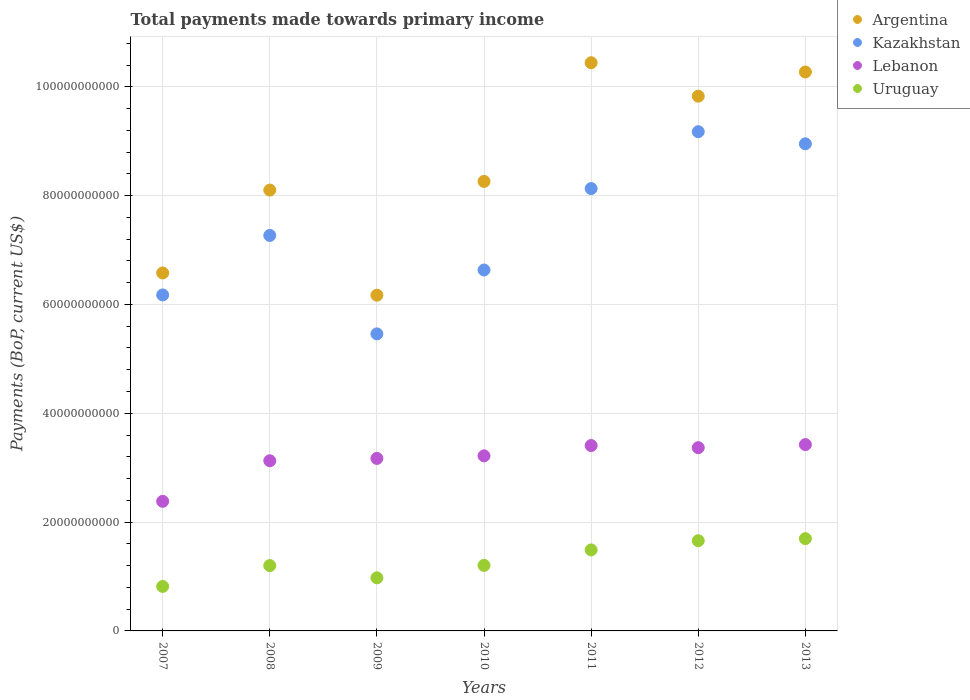How many different coloured dotlines are there?
Give a very brief answer. 4. Is the number of dotlines equal to the number of legend labels?
Make the answer very short. Yes. What is the total payments made towards primary income in Kazakhstan in 2011?
Keep it short and to the point. 8.13e+1. Across all years, what is the maximum total payments made towards primary income in Kazakhstan?
Offer a terse response. 9.18e+1. Across all years, what is the minimum total payments made towards primary income in Argentina?
Give a very brief answer. 6.17e+1. In which year was the total payments made towards primary income in Uruguay maximum?
Give a very brief answer. 2013. What is the total total payments made towards primary income in Argentina in the graph?
Provide a succinct answer. 5.97e+11. What is the difference between the total payments made towards primary income in Lebanon in 2009 and that in 2010?
Offer a very short reply. -4.73e+08. What is the difference between the total payments made towards primary income in Lebanon in 2013 and the total payments made towards primary income in Kazakhstan in 2008?
Your answer should be very brief. -3.84e+1. What is the average total payments made towards primary income in Uruguay per year?
Provide a short and direct response. 1.29e+1. In the year 2013, what is the difference between the total payments made towards primary income in Uruguay and total payments made towards primary income in Kazakhstan?
Your response must be concise. -7.26e+1. In how many years, is the total payments made towards primary income in Lebanon greater than 68000000000 US$?
Give a very brief answer. 0. What is the ratio of the total payments made towards primary income in Lebanon in 2011 to that in 2013?
Ensure brevity in your answer.  0.99. What is the difference between the highest and the second highest total payments made towards primary income in Argentina?
Make the answer very short. 1.70e+09. What is the difference between the highest and the lowest total payments made towards primary income in Kazakhstan?
Provide a succinct answer. 3.72e+1. In how many years, is the total payments made towards primary income in Argentina greater than the average total payments made towards primary income in Argentina taken over all years?
Offer a terse response. 3. Is it the case that in every year, the sum of the total payments made towards primary income in Uruguay and total payments made towards primary income in Kazakhstan  is greater than the total payments made towards primary income in Argentina?
Your answer should be compact. No. Does the total payments made towards primary income in Kazakhstan monotonically increase over the years?
Keep it short and to the point. No. Is the total payments made towards primary income in Uruguay strictly greater than the total payments made towards primary income in Kazakhstan over the years?
Your answer should be very brief. No. Is the total payments made towards primary income in Lebanon strictly less than the total payments made towards primary income in Kazakhstan over the years?
Keep it short and to the point. Yes. How many dotlines are there?
Offer a very short reply. 4. How many years are there in the graph?
Provide a succinct answer. 7. Does the graph contain any zero values?
Your answer should be very brief. No. Does the graph contain grids?
Your answer should be very brief. Yes. Where does the legend appear in the graph?
Provide a short and direct response. Top right. What is the title of the graph?
Your answer should be very brief. Total payments made towards primary income. Does "Mauritius" appear as one of the legend labels in the graph?
Keep it short and to the point. No. What is the label or title of the Y-axis?
Offer a very short reply. Payments (BoP, current US$). What is the Payments (BoP, current US$) in Argentina in 2007?
Your answer should be compact. 6.58e+1. What is the Payments (BoP, current US$) in Kazakhstan in 2007?
Make the answer very short. 6.18e+1. What is the Payments (BoP, current US$) in Lebanon in 2007?
Provide a short and direct response. 2.38e+1. What is the Payments (BoP, current US$) of Uruguay in 2007?
Your answer should be very brief. 8.18e+09. What is the Payments (BoP, current US$) in Argentina in 2008?
Offer a very short reply. 8.10e+1. What is the Payments (BoP, current US$) of Kazakhstan in 2008?
Your answer should be very brief. 7.27e+1. What is the Payments (BoP, current US$) in Lebanon in 2008?
Provide a short and direct response. 3.13e+1. What is the Payments (BoP, current US$) in Uruguay in 2008?
Provide a succinct answer. 1.20e+1. What is the Payments (BoP, current US$) of Argentina in 2009?
Ensure brevity in your answer.  6.17e+1. What is the Payments (BoP, current US$) of Kazakhstan in 2009?
Ensure brevity in your answer.  5.46e+1. What is the Payments (BoP, current US$) of Lebanon in 2009?
Provide a short and direct response. 3.17e+1. What is the Payments (BoP, current US$) of Uruguay in 2009?
Offer a very short reply. 9.76e+09. What is the Payments (BoP, current US$) in Argentina in 2010?
Offer a very short reply. 8.26e+1. What is the Payments (BoP, current US$) in Kazakhstan in 2010?
Provide a short and direct response. 6.63e+1. What is the Payments (BoP, current US$) in Lebanon in 2010?
Give a very brief answer. 3.22e+1. What is the Payments (BoP, current US$) in Uruguay in 2010?
Give a very brief answer. 1.20e+1. What is the Payments (BoP, current US$) of Argentina in 2011?
Ensure brevity in your answer.  1.04e+11. What is the Payments (BoP, current US$) in Kazakhstan in 2011?
Give a very brief answer. 8.13e+1. What is the Payments (BoP, current US$) of Lebanon in 2011?
Offer a terse response. 3.41e+1. What is the Payments (BoP, current US$) in Uruguay in 2011?
Your answer should be compact. 1.49e+1. What is the Payments (BoP, current US$) of Argentina in 2012?
Provide a short and direct response. 9.83e+1. What is the Payments (BoP, current US$) in Kazakhstan in 2012?
Offer a terse response. 9.18e+1. What is the Payments (BoP, current US$) in Lebanon in 2012?
Provide a short and direct response. 3.37e+1. What is the Payments (BoP, current US$) in Uruguay in 2012?
Your response must be concise. 1.66e+1. What is the Payments (BoP, current US$) in Argentina in 2013?
Your answer should be very brief. 1.03e+11. What is the Payments (BoP, current US$) of Kazakhstan in 2013?
Keep it short and to the point. 8.95e+1. What is the Payments (BoP, current US$) of Lebanon in 2013?
Your answer should be very brief. 3.42e+1. What is the Payments (BoP, current US$) in Uruguay in 2013?
Ensure brevity in your answer.  1.70e+1. Across all years, what is the maximum Payments (BoP, current US$) of Argentina?
Offer a terse response. 1.04e+11. Across all years, what is the maximum Payments (BoP, current US$) in Kazakhstan?
Make the answer very short. 9.18e+1. Across all years, what is the maximum Payments (BoP, current US$) of Lebanon?
Offer a terse response. 3.42e+1. Across all years, what is the maximum Payments (BoP, current US$) of Uruguay?
Your answer should be very brief. 1.70e+1. Across all years, what is the minimum Payments (BoP, current US$) in Argentina?
Offer a terse response. 6.17e+1. Across all years, what is the minimum Payments (BoP, current US$) in Kazakhstan?
Provide a short and direct response. 5.46e+1. Across all years, what is the minimum Payments (BoP, current US$) in Lebanon?
Your answer should be compact. 2.38e+1. Across all years, what is the minimum Payments (BoP, current US$) in Uruguay?
Ensure brevity in your answer.  8.18e+09. What is the total Payments (BoP, current US$) in Argentina in the graph?
Make the answer very short. 5.97e+11. What is the total Payments (BoP, current US$) of Kazakhstan in the graph?
Your answer should be compact. 5.18e+11. What is the total Payments (BoP, current US$) in Lebanon in the graph?
Provide a succinct answer. 2.21e+11. What is the total Payments (BoP, current US$) in Uruguay in the graph?
Offer a terse response. 9.04e+1. What is the difference between the Payments (BoP, current US$) of Argentina in 2007 and that in 2008?
Give a very brief answer. -1.52e+1. What is the difference between the Payments (BoP, current US$) of Kazakhstan in 2007 and that in 2008?
Your response must be concise. -1.09e+1. What is the difference between the Payments (BoP, current US$) of Lebanon in 2007 and that in 2008?
Give a very brief answer. -7.46e+09. What is the difference between the Payments (BoP, current US$) in Uruguay in 2007 and that in 2008?
Your answer should be compact. -3.83e+09. What is the difference between the Payments (BoP, current US$) of Argentina in 2007 and that in 2009?
Your answer should be compact. 4.09e+09. What is the difference between the Payments (BoP, current US$) of Kazakhstan in 2007 and that in 2009?
Your answer should be very brief. 7.15e+09. What is the difference between the Payments (BoP, current US$) in Lebanon in 2007 and that in 2009?
Provide a succinct answer. -7.89e+09. What is the difference between the Payments (BoP, current US$) of Uruguay in 2007 and that in 2009?
Your answer should be compact. -1.59e+09. What is the difference between the Payments (BoP, current US$) in Argentina in 2007 and that in 2010?
Your answer should be compact. -1.68e+1. What is the difference between the Payments (BoP, current US$) of Kazakhstan in 2007 and that in 2010?
Provide a short and direct response. -4.59e+09. What is the difference between the Payments (BoP, current US$) in Lebanon in 2007 and that in 2010?
Make the answer very short. -8.36e+09. What is the difference between the Payments (BoP, current US$) in Uruguay in 2007 and that in 2010?
Your response must be concise. -3.87e+09. What is the difference between the Payments (BoP, current US$) in Argentina in 2007 and that in 2011?
Provide a succinct answer. -3.86e+1. What is the difference between the Payments (BoP, current US$) in Kazakhstan in 2007 and that in 2011?
Make the answer very short. -1.96e+1. What is the difference between the Payments (BoP, current US$) in Lebanon in 2007 and that in 2011?
Offer a very short reply. -1.03e+1. What is the difference between the Payments (BoP, current US$) of Uruguay in 2007 and that in 2011?
Your response must be concise. -6.71e+09. What is the difference between the Payments (BoP, current US$) in Argentina in 2007 and that in 2012?
Your answer should be compact. -3.25e+1. What is the difference between the Payments (BoP, current US$) of Kazakhstan in 2007 and that in 2012?
Your response must be concise. -3.00e+1. What is the difference between the Payments (BoP, current US$) of Lebanon in 2007 and that in 2012?
Give a very brief answer. -9.86e+09. What is the difference between the Payments (BoP, current US$) in Uruguay in 2007 and that in 2012?
Give a very brief answer. -8.41e+09. What is the difference between the Payments (BoP, current US$) in Argentina in 2007 and that in 2013?
Make the answer very short. -3.69e+1. What is the difference between the Payments (BoP, current US$) of Kazakhstan in 2007 and that in 2013?
Keep it short and to the point. -2.78e+1. What is the difference between the Payments (BoP, current US$) in Lebanon in 2007 and that in 2013?
Make the answer very short. -1.04e+1. What is the difference between the Payments (BoP, current US$) of Uruguay in 2007 and that in 2013?
Your answer should be very brief. -8.79e+09. What is the difference between the Payments (BoP, current US$) of Argentina in 2008 and that in 2009?
Offer a terse response. 1.93e+1. What is the difference between the Payments (BoP, current US$) in Kazakhstan in 2008 and that in 2009?
Provide a succinct answer. 1.81e+1. What is the difference between the Payments (BoP, current US$) of Lebanon in 2008 and that in 2009?
Give a very brief answer. -4.30e+08. What is the difference between the Payments (BoP, current US$) in Uruguay in 2008 and that in 2009?
Give a very brief answer. 2.24e+09. What is the difference between the Payments (BoP, current US$) in Argentina in 2008 and that in 2010?
Provide a succinct answer. -1.59e+09. What is the difference between the Payments (BoP, current US$) in Kazakhstan in 2008 and that in 2010?
Offer a very short reply. 6.35e+09. What is the difference between the Payments (BoP, current US$) in Lebanon in 2008 and that in 2010?
Give a very brief answer. -9.03e+08. What is the difference between the Payments (BoP, current US$) of Uruguay in 2008 and that in 2010?
Provide a short and direct response. -3.72e+07. What is the difference between the Payments (BoP, current US$) of Argentina in 2008 and that in 2011?
Your response must be concise. -2.34e+1. What is the difference between the Payments (BoP, current US$) of Kazakhstan in 2008 and that in 2011?
Your response must be concise. -8.61e+09. What is the difference between the Payments (BoP, current US$) of Lebanon in 2008 and that in 2011?
Your answer should be compact. -2.80e+09. What is the difference between the Payments (BoP, current US$) in Uruguay in 2008 and that in 2011?
Your answer should be compact. -2.88e+09. What is the difference between the Payments (BoP, current US$) of Argentina in 2008 and that in 2012?
Keep it short and to the point. -1.73e+1. What is the difference between the Payments (BoP, current US$) in Kazakhstan in 2008 and that in 2012?
Give a very brief answer. -1.91e+1. What is the difference between the Payments (BoP, current US$) in Lebanon in 2008 and that in 2012?
Your response must be concise. -2.40e+09. What is the difference between the Payments (BoP, current US$) in Uruguay in 2008 and that in 2012?
Your response must be concise. -4.57e+09. What is the difference between the Payments (BoP, current US$) in Argentina in 2008 and that in 2013?
Your answer should be very brief. -2.17e+1. What is the difference between the Payments (BoP, current US$) of Kazakhstan in 2008 and that in 2013?
Ensure brevity in your answer.  -1.68e+1. What is the difference between the Payments (BoP, current US$) in Lebanon in 2008 and that in 2013?
Provide a succinct answer. -2.97e+09. What is the difference between the Payments (BoP, current US$) of Uruguay in 2008 and that in 2013?
Your answer should be very brief. -4.95e+09. What is the difference between the Payments (BoP, current US$) in Argentina in 2009 and that in 2010?
Give a very brief answer. -2.09e+1. What is the difference between the Payments (BoP, current US$) in Kazakhstan in 2009 and that in 2010?
Keep it short and to the point. -1.17e+1. What is the difference between the Payments (BoP, current US$) in Lebanon in 2009 and that in 2010?
Provide a short and direct response. -4.73e+08. What is the difference between the Payments (BoP, current US$) in Uruguay in 2009 and that in 2010?
Keep it short and to the point. -2.28e+09. What is the difference between the Payments (BoP, current US$) in Argentina in 2009 and that in 2011?
Offer a very short reply. -4.27e+1. What is the difference between the Payments (BoP, current US$) in Kazakhstan in 2009 and that in 2011?
Keep it short and to the point. -2.67e+1. What is the difference between the Payments (BoP, current US$) in Lebanon in 2009 and that in 2011?
Provide a short and direct response. -2.37e+09. What is the difference between the Payments (BoP, current US$) of Uruguay in 2009 and that in 2011?
Your answer should be compact. -5.13e+09. What is the difference between the Payments (BoP, current US$) in Argentina in 2009 and that in 2012?
Make the answer very short. -3.66e+1. What is the difference between the Payments (BoP, current US$) of Kazakhstan in 2009 and that in 2012?
Your response must be concise. -3.72e+1. What is the difference between the Payments (BoP, current US$) of Lebanon in 2009 and that in 2012?
Make the answer very short. -1.98e+09. What is the difference between the Payments (BoP, current US$) of Uruguay in 2009 and that in 2012?
Provide a succinct answer. -6.82e+09. What is the difference between the Payments (BoP, current US$) in Argentina in 2009 and that in 2013?
Keep it short and to the point. -4.10e+1. What is the difference between the Payments (BoP, current US$) in Kazakhstan in 2009 and that in 2013?
Give a very brief answer. -3.49e+1. What is the difference between the Payments (BoP, current US$) in Lebanon in 2009 and that in 2013?
Make the answer very short. -2.54e+09. What is the difference between the Payments (BoP, current US$) of Uruguay in 2009 and that in 2013?
Your answer should be compact. -7.20e+09. What is the difference between the Payments (BoP, current US$) in Argentina in 2010 and that in 2011?
Give a very brief answer. -2.18e+1. What is the difference between the Payments (BoP, current US$) of Kazakhstan in 2010 and that in 2011?
Make the answer very short. -1.50e+1. What is the difference between the Payments (BoP, current US$) in Lebanon in 2010 and that in 2011?
Offer a very short reply. -1.89e+09. What is the difference between the Payments (BoP, current US$) of Uruguay in 2010 and that in 2011?
Ensure brevity in your answer.  -2.85e+09. What is the difference between the Payments (BoP, current US$) of Argentina in 2010 and that in 2012?
Your answer should be very brief. -1.57e+1. What is the difference between the Payments (BoP, current US$) in Kazakhstan in 2010 and that in 2012?
Your answer should be compact. -2.54e+1. What is the difference between the Payments (BoP, current US$) of Lebanon in 2010 and that in 2012?
Give a very brief answer. -1.50e+09. What is the difference between the Payments (BoP, current US$) of Uruguay in 2010 and that in 2012?
Your answer should be very brief. -4.54e+09. What is the difference between the Payments (BoP, current US$) of Argentina in 2010 and that in 2013?
Keep it short and to the point. -2.01e+1. What is the difference between the Payments (BoP, current US$) in Kazakhstan in 2010 and that in 2013?
Provide a short and direct response. -2.32e+1. What is the difference between the Payments (BoP, current US$) in Lebanon in 2010 and that in 2013?
Provide a succinct answer. -2.07e+09. What is the difference between the Payments (BoP, current US$) of Uruguay in 2010 and that in 2013?
Your answer should be compact. -4.92e+09. What is the difference between the Payments (BoP, current US$) of Argentina in 2011 and that in 2012?
Your response must be concise. 6.14e+09. What is the difference between the Payments (BoP, current US$) in Kazakhstan in 2011 and that in 2012?
Keep it short and to the point. -1.05e+1. What is the difference between the Payments (BoP, current US$) in Lebanon in 2011 and that in 2012?
Provide a succinct answer. 3.91e+08. What is the difference between the Payments (BoP, current US$) of Uruguay in 2011 and that in 2012?
Offer a terse response. -1.69e+09. What is the difference between the Payments (BoP, current US$) in Argentina in 2011 and that in 2013?
Ensure brevity in your answer.  1.70e+09. What is the difference between the Payments (BoP, current US$) in Kazakhstan in 2011 and that in 2013?
Your answer should be compact. -8.23e+09. What is the difference between the Payments (BoP, current US$) of Lebanon in 2011 and that in 2013?
Ensure brevity in your answer.  -1.74e+08. What is the difference between the Payments (BoP, current US$) in Uruguay in 2011 and that in 2013?
Make the answer very short. -2.07e+09. What is the difference between the Payments (BoP, current US$) in Argentina in 2012 and that in 2013?
Give a very brief answer. -4.44e+09. What is the difference between the Payments (BoP, current US$) in Kazakhstan in 2012 and that in 2013?
Ensure brevity in your answer.  2.23e+09. What is the difference between the Payments (BoP, current US$) in Lebanon in 2012 and that in 2013?
Offer a terse response. -5.64e+08. What is the difference between the Payments (BoP, current US$) in Uruguay in 2012 and that in 2013?
Offer a terse response. -3.80e+08. What is the difference between the Payments (BoP, current US$) in Argentina in 2007 and the Payments (BoP, current US$) in Kazakhstan in 2008?
Offer a very short reply. -6.89e+09. What is the difference between the Payments (BoP, current US$) in Argentina in 2007 and the Payments (BoP, current US$) in Lebanon in 2008?
Offer a very short reply. 3.45e+1. What is the difference between the Payments (BoP, current US$) of Argentina in 2007 and the Payments (BoP, current US$) of Uruguay in 2008?
Give a very brief answer. 5.38e+1. What is the difference between the Payments (BoP, current US$) of Kazakhstan in 2007 and the Payments (BoP, current US$) of Lebanon in 2008?
Offer a terse response. 3.05e+1. What is the difference between the Payments (BoP, current US$) in Kazakhstan in 2007 and the Payments (BoP, current US$) in Uruguay in 2008?
Your answer should be very brief. 4.97e+1. What is the difference between the Payments (BoP, current US$) of Lebanon in 2007 and the Payments (BoP, current US$) of Uruguay in 2008?
Make the answer very short. 1.18e+1. What is the difference between the Payments (BoP, current US$) in Argentina in 2007 and the Payments (BoP, current US$) in Kazakhstan in 2009?
Provide a short and direct response. 1.12e+1. What is the difference between the Payments (BoP, current US$) of Argentina in 2007 and the Payments (BoP, current US$) of Lebanon in 2009?
Your answer should be very brief. 3.41e+1. What is the difference between the Payments (BoP, current US$) in Argentina in 2007 and the Payments (BoP, current US$) in Uruguay in 2009?
Provide a succinct answer. 5.60e+1. What is the difference between the Payments (BoP, current US$) in Kazakhstan in 2007 and the Payments (BoP, current US$) in Lebanon in 2009?
Provide a short and direct response. 3.00e+1. What is the difference between the Payments (BoP, current US$) in Kazakhstan in 2007 and the Payments (BoP, current US$) in Uruguay in 2009?
Give a very brief answer. 5.20e+1. What is the difference between the Payments (BoP, current US$) in Lebanon in 2007 and the Payments (BoP, current US$) in Uruguay in 2009?
Make the answer very short. 1.41e+1. What is the difference between the Payments (BoP, current US$) of Argentina in 2007 and the Payments (BoP, current US$) of Kazakhstan in 2010?
Offer a terse response. -5.44e+08. What is the difference between the Payments (BoP, current US$) of Argentina in 2007 and the Payments (BoP, current US$) of Lebanon in 2010?
Your answer should be very brief. 3.36e+1. What is the difference between the Payments (BoP, current US$) in Argentina in 2007 and the Payments (BoP, current US$) in Uruguay in 2010?
Your answer should be compact. 5.37e+1. What is the difference between the Payments (BoP, current US$) of Kazakhstan in 2007 and the Payments (BoP, current US$) of Lebanon in 2010?
Your answer should be compact. 2.96e+1. What is the difference between the Payments (BoP, current US$) of Kazakhstan in 2007 and the Payments (BoP, current US$) of Uruguay in 2010?
Your answer should be compact. 4.97e+1. What is the difference between the Payments (BoP, current US$) in Lebanon in 2007 and the Payments (BoP, current US$) in Uruguay in 2010?
Keep it short and to the point. 1.18e+1. What is the difference between the Payments (BoP, current US$) in Argentina in 2007 and the Payments (BoP, current US$) in Kazakhstan in 2011?
Your response must be concise. -1.55e+1. What is the difference between the Payments (BoP, current US$) in Argentina in 2007 and the Payments (BoP, current US$) in Lebanon in 2011?
Provide a succinct answer. 3.17e+1. What is the difference between the Payments (BoP, current US$) in Argentina in 2007 and the Payments (BoP, current US$) in Uruguay in 2011?
Offer a very short reply. 5.09e+1. What is the difference between the Payments (BoP, current US$) in Kazakhstan in 2007 and the Payments (BoP, current US$) in Lebanon in 2011?
Provide a short and direct response. 2.77e+1. What is the difference between the Payments (BoP, current US$) in Kazakhstan in 2007 and the Payments (BoP, current US$) in Uruguay in 2011?
Provide a short and direct response. 4.69e+1. What is the difference between the Payments (BoP, current US$) of Lebanon in 2007 and the Payments (BoP, current US$) of Uruguay in 2011?
Your response must be concise. 8.93e+09. What is the difference between the Payments (BoP, current US$) in Argentina in 2007 and the Payments (BoP, current US$) in Kazakhstan in 2012?
Make the answer very short. -2.60e+1. What is the difference between the Payments (BoP, current US$) in Argentina in 2007 and the Payments (BoP, current US$) in Lebanon in 2012?
Your answer should be compact. 3.21e+1. What is the difference between the Payments (BoP, current US$) of Argentina in 2007 and the Payments (BoP, current US$) of Uruguay in 2012?
Keep it short and to the point. 4.92e+1. What is the difference between the Payments (BoP, current US$) of Kazakhstan in 2007 and the Payments (BoP, current US$) of Lebanon in 2012?
Your answer should be very brief. 2.81e+1. What is the difference between the Payments (BoP, current US$) of Kazakhstan in 2007 and the Payments (BoP, current US$) of Uruguay in 2012?
Make the answer very short. 4.52e+1. What is the difference between the Payments (BoP, current US$) of Lebanon in 2007 and the Payments (BoP, current US$) of Uruguay in 2012?
Make the answer very short. 7.24e+09. What is the difference between the Payments (BoP, current US$) in Argentina in 2007 and the Payments (BoP, current US$) in Kazakhstan in 2013?
Provide a short and direct response. -2.37e+1. What is the difference between the Payments (BoP, current US$) of Argentina in 2007 and the Payments (BoP, current US$) of Lebanon in 2013?
Ensure brevity in your answer.  3.15e+1. What is the difference between the Payments (BoP, current US$) of Argentina in 2007 and the Payments (BoP, current US$) of Uruguay in 2013?
Your response must be concise. 4.88e+1. What is the difference between the Payments (BoP, current US$) in Kazakhstan in 2007 and the Payments (BoP, current US$) in Lebanon in 2013?
Offer a terse response. 2.75e+1. What is the difference between the Payments (BoP, current US$) in Kazakhstan in 2007 and the Payments (BoP, current US$) in Uruguay in 2013?
Your answer should be compact. 4.48e+1. What is the difference between the Payments (BoP, current US$) of Lebanon in 2007 and the Payments (BoP, current US$) of Uruguay in 2013?
Ensure brevity in your answer.  6.86e+09. What is the difference between the Payments (BoP, current US$) of Argentina in 2008 and the Payments (BoP, current US$) of Kazakhstan in 2009?
Your answer should be very brief. 2.64e+1. What is the difference between the Payments (BoP, current US$) of Argentina in 2008 and the Payments (BoP, current US$) of Lebanon in 2009?
Make the answer very short. 4.93e+1. What is the difference between the Payments (BoP, current US$) in Argentina in 2008 and the Payments (BoP, current US$) in Uruguay in 2009?
Give a very brief answer. 7.13e+1. What is the difference between the Payments (BoP, current US$) in Kazakhstan in 2008 and the Payments (BoP, current US$) in Lebanon in 2009?
Give a very brief answer. 4.10e+1. What is the difference between the Payments (BoP, current US$) of Kazakhstan in 2008 and the Payments (BoP, current US$) of Uruguay in 2009?
Offer a very short reply. 6.29e+1. What is the difference between the Payments (BoP, current US$) in Lebanon in 2008 and the Payments (BoP, current US$) in Uruguay in 2009?
Provide a short and direct response. 2.15e+1. What is the difference between the Payments (BoP, current US$) of Argentina in 2008 and the Payments (BoP, current US$) of Kazakhstan in 2010?
Give a very brief answer. 1.47e+1. What is the difference between the Payments (BoP, current US$) of Argentina in 2008 and the Payments (BoP, current US$) of Lebanon in 2010?
Make the answer very short. 4.88e+1. What is the difference between the Payments (BoP, current US$) in Argentina in 2008 and the Payments (BoP, current US$) in Uruguay in 2010?
Give a very brief answer. 6.90e+1. What is the difference between the Payments (BoP, current US$) of Kazakhstan in 2008 and the Payments (BoP, current US$) of Lebanon in 2010?
Your answer should be compact. 4.05e+1. What is the difference between the Payments (BoP, current US$) in Kazakhstan in 2008 and the Payments (BoP, current US$) in Uruguay in 2010?
Your answer should be compact. 6.06e+1. What is the difference between the Payments (BoP, current US$) in Lebanon in 2008 and the Payments (BoP, current US$) in Uruguay in 2010?
Your answer should be compact. 1.92e+1. What is the difference between the Payments (BoP, current US$) in Argentina in 2008 and the Payments (BoP, current US$) in Kazakhstan in 2011?
Make the answer very short. -2.78e+08. What is the difference between the Payments (BoP, current US$) of Argentina in 2008 and the Payments (BoP, current US$) of Lebanon in 2011?
Offer a terse response. 4.70e+1. What is the difference between the Payments (BoP, current US$) in Argentina in 2008 and the Payments (BoP, current US$) in Uruguay in 2011?
Ensure brevity in your answer.  6.61e+1. What is the difference between the Payments (BoP, current US$) in Kazakhstan in 2008 and the Payments (BoP, current US$) in Lebanon in 2011?
Your response must be concise. 3.86e+1. What is the difference between the Payments (BoP, current US$) of Kazakhstan in 2008 and the Payments (BoP, current US$) of Uruguay in 2011?
Offer a terse response. 5.78e+1. What is the difference between the Payments (BoP, current US$) of Lebanon in 2008 and the Payments (BoP, current US$) of Uruguay in 2011?
Offer a very short reply. 1.64e+1. What is the difference between the Payments (BoP, current US$) of Argentina in 2008 and the Payments (BoP, current US$) of Kazakhstan in 2012?
Give a very brief answer. -1.07e+1. What is the difference between the Payments (BoP, current US$) of Argentina in 2008 and the Payments (BoP, current US$) of Lebanon in 2012?
Keep it short and to the point. 4.73e+1. What is the difference between the Payments (BoP, current US$) in Argentina in 2008 and the Payments (BoP, current US$) in Uruguay in 2012?
Provide a succinct answer. 6.44e+1. What is the difference between the Payments (BoP, current US$) in Kazakhstan in 2008 and the Payments (BoP, current US$) in Lebanon in 2012?
Offer a terse response. 3.90e+1. What is the difference between the Payments (BoP, current US$) of Kazakhstan in 2008 and the Payments (BoP, current US$) of Uruguay in 2012?
Offer a very short reply. 5.61e+1. What is the difference between the Payments (BoP, current US$) in Lebanon in 2008 and the Payments (BoP, current US$) in Uruguay in 2012?
Make the answer very short. 1.47e+1. What is the difference between the Payments (BoP, current US$) of Argentina in 2008 and the Payments (BoP, current US$) of Kazakhstan in 2013?
Provide a short and direct response. -8.50e+09. What is the difference between the Payments (BoP, current US$) in Argentina in 2008 and the Payments (BoP, current US$) in Lebanon in 2013?
Your answer should be very brief. 4.68e+1. What is the difference between the Payments (BoP, current US$) of Argentina in 2008 and the Payments (BoP, current US$) of Uruguay in 2013?
Provide a succinct answer. 6.41e+1. What is the difference between the Payments (BoP, current US$) in Kazakhstan in 2008 and the Payments (BoP, current US$) in Lebanon in 2013?
Ensure brevity in your answer.  3.84e+1. What is the difference between the Payments (BoP, current US$) in Kazakhstan in 2008 and the Payments (BoP, current US$) in Uruguay in 2013?
Provide a succinct answer. 5.57e+1. What is the difference between the Payments (BoP, current US$) of Lebanon in 2008 and the Payments (BoP, current US$) of Uruguay in 2013?
Provide a short and direct response. 1.43e+1. What is the difference between the Payments (BoP, current US$) in Argentina in 2009 and the Payments (BoP, current US$) in Kazakhstan in 2010?
Give a very brief answer. -4.63e+09. What is the difference between the Payments (BoP, current US$) of Argentina in 2009 and the Payments (BoP, current US$) of Lebanon in 2010?
Offer a terse response. 2.95e+1. What is the difference between the Payments (BoP, current US$) in Argentina in 2009 and the Payments (BoP, current US$) in Uruguay in 2010?
Provide a short and direct response. 4.97e+1. What is the difference between the Payments (BoP, current US$) in Kazakhstan in 2009 and the Payments (BoP, current US$) in Lebanon in 2010?
Make the answer very short. 2.24e+1. What is the difference between the Payments (BoP, current US$) of Kazakhstan in 2009 and the Payments (BoP, current US$) of Uruguay in 2010?
Your answer should be compact. 4.26e+1. What is the difference between the Payments (BoP, current US$) in Lebanon in 2009 and the Payments (BoP, current US$) in Uruguay in 2010?
Your response must be concise. 1.97e+1. What is the difference between the Payments (BoP, current US$) in Argentina in 2009 and the Payments (BoP, current US$) in Kazakhstan in 2011?
Provide a succinct answer. -1.96e+1. What is the difference between the Payments (BoP, current US$) of Argentina in 2009 and the Payments (BoP, current US$) of Lebanon in 2011?
Offer a terse response. 2.76e+1. What is the difference between the Payments (BoP, current US$) in Argentina in 2009 and the Payments (BoP, current US$) in Uruguay in 2011?
Keep it short and to the point. 4.68e+1. What is the difference between the Payments (BoP, current US$) in Kazakhstan in 2009 and the Payments (BoP, current US$) in Lebanon in 2011?
Your answer should be compact. 2.05e+1. What is the difference between the Payments (BoP, current US$) in Kazakhstan in 2009 and the Payments (BoP, current US$) in Uruguay in 2011?
Keep it short and to the point. 3.97e+1. What is the difference between the Payments (BoP, current US$) of Lebanon in 2009 and the Payments (BoP, current US$) of Uruguay in 2011?
Give a very brief answer. 1.68e+1. What is the difference between the Payments (BoP, current US$) of Argentina in 2009 and the Payments (BoP, current US$) of Kazakhstan in 2012?
Keep it short and to the point. -3.00e+1. What is the difference between the Payments (BoP, current US$) of Argentina in 2009 and the Payments (BoP, current US$) of Lebanon in 2012?
Ensure brevity in your answer.  2.80e+1. What is the difference between the Payments (BoP, current US$) of Argentina in 2009 and the Payments (BoP, current US$) of Uruguay in 2012?
Your answer should be compact. 4.51e+1. What is the difference between the Payments (BoP, current US$) of Kazakhstan in 2009 and the Payments (BoP, current US$) of Lebanon in 2012?
Your answer should be very brief. 2.09e+1. What is the difference between the Payments (BoP, current US$) of Kazakhstan in 2009 and the Payments (BoP, current US$) of Uruguay in 2012?
Your answer should be very brief. 3.80e+1. What is the difference between the Payments (BoP, current US$) in Lebanon in 2009 and the Payments (BoP, current US$) in Uruguay in 2012?
Provide a succinct answer. 1.51e+1. What is the difference between the Payments (BoP, current US$) in Argentina in 2009 and the Payments (BoP, current US$) in Kazakhstan in 2013?
Make the answer very short. -2.78e+1. What is the difference between the Payments (BoP, current US$) of Argentina in 2009 and the Payments (BoP, current US$) of Lebanon in 2013?
Your response must be concise. 2.75e+1. What is the difference between the Payments (BoP, current US$) of Argentina in 2009 and the Payments (BoP, current US$) of Uruguay in 2013?
Keep it short and to the point. 4.47e+1. What is the difference between the Payments (BoP, current US$) in Kazakhstan in 2009 and the Payments (BoP, current US$) in Lebanon in 2013?
Offer a very short reply. 2.04e+1. What is the difference between the Payments (BoP, current US$) in Kazakhstan in 2009 and the Payments (BoP, current US$) in Uruguay in 2013?
Give a very brief answer. 3.76e+1. What is the difference between the Payments (BoP, current US$) in Lebanon in 2009 and the Payments (BoP, current US$) in Uruguay in 2013?
Provide a succinct answer. 1.47e+1. What is the difference between the Payments (BoP, current US$) of Argentina in 2010 and the Payments (BoP, current US$) of Kazakhstan in 2011?
Your answer should be compact. 1.31e+09. What is the difference between the Payments (BoP, current US$) in Argentina in 2010 and the Payments (BoP, current US$) in Lebanon in 2011?
Offer a very short reply. 4.85e+1. What is the difference between the Payments (BoP, current US$) of Argentina in 2010 and the Payments (BoP, current US$) of Uruguay in 2011?
Your response must be concise. 6.77e+1. What is the difference between the Payments (BoP, current US$) of Kazakhstan in 2010 and the Payments (BoP, current US$) of Lebanon in 2011?
Give a very brief answer. 3.23e+1. What is the difference between the Payments (BoP, current US$) in Kazakhstan in 2010 and the Payments (BoP, current US$) in Uruguay in 2011?
Your answer should be compact. 5.14e+1. What is the difference between the Payments (BoP, current US$) in Lebanon in 2010 and the Payments (BoP, current US$) in Uruguay in 2011?
Offer a very short reply. 1.73e+1. What is the difference between the Payments (BoP, current US$) of Argentina in 2010 and the Payments (BoP, current US$) of Kazakhstan in 2012?
Keep it short and to the point. -9.14e+09. What is the difference between the Payments (BoP, current US$) in Argentina in 2010 and the Payments (BoP, current US$) in Lebanon in 2012?
Ensure brevity in your answer.  4.89e+1. What is the difference between the Payments (BoP, current US$) of Argentina in 2010 and the Payments (BoP, current US$) of Uruguay in 2012?
Your answer should be compact. 6.60e+1. What is the difference between the Payments (BoP, current US$) in Kazakhstan in 2010 and the Payments (BoP, current US$) in Lebanon in 2012?
Give a very brief answer. 3.27e+1. What is the difference between the Payments (BoP, current US$) of Kazakhstan in 2010 and the Payments (BoP, current US$) of Uruguay in 2012?
Keep it short and to the point. 4.98e+1. What is the difference between the Payments (BoP, current US$) of Lebanon in 2010 and the Payments (BoP, current US$) of Uruguay in 2012?
Ensure brevity in your answer.  1.56e+1. What is the difference between the Payments (BoP, current US$) of Argentina in 2010 and the Payments (BoP, current US$) of Kazakhstan in 2013?
Ensure brevity in your answer.  -6.91e+09. What is the difference between the Payments (BoP, current US$) of Argentina in 2010 and the Payments (BoP, current US$) of Lebanon in 2013?
Make the answer very short. 4.84e+1. What is the difference between the Payments (BoP, current US$) in Argentina in 2010 and the Payments (BoP, current US$) in Uruguay in 2013?
Make the answer very short. 6.57e+1. What is the difference between the Payments (BoP, current US$) in Kazakhstan in 2010 and the Payments (BoP, current US$) in Lebanon in 2013?
Your response must be concise. 3.21e+1. What is the difference between the Payments (BoP, current US$) of Kazakhstan in 2010 and the Payments (BoP, current US$) of Uruguay in 2013?
Provide a succinct answer. 4.94e+1. What is the difference between the Payments (BoP, current US$) in Lebanon in 2010 and the Payments (BoP, current US$) in Uruguay in 2013?
Offer a terse response. 1.52e+1. What is the difference between the Payments (BoP, current US$) in Argentina in 2011 and the Payments (BoP, current US$) in Kazakhstan in 2012?
Keep it short and to the point. 1.27e+1. What is the difference between the Payments (BoP, current US$) in Argentina in 2011 and the Payments (BoP, current US$) in Lebanon in 2012?
Keep it short and to the point. 7.07e+1. What is the difference between the Payments (BoP, current US$) in Argentina in 2011 and the Payments (BoP, current US$) in Uruguay in 2012?
Your response must be concise. 8.78e+1. What is the difference between the Payments (BoP, current US$) of Kazakhstan in 2011 and the Payments (BoP, current US$) of Lebanon in 2012?
Make the answer very short. 4.76e+1. What is the difference between the Payments (BoP, current US$) in Kazakhstan in 2011 and the Payments (BoP, current US$) in Uruguay in 2012?
Your answer should be very brief. 6.47e+1. What is the difference between the Payments (BoP, current US$) in Lebanon in 2011 and the Payments (BoP, current US$) in Uruguay in 2012?
Provide a succinct answer. 1.75e+1. What is the difference between the Payments (BoP, current US$) of Argentina in 2011 and the Payments (BoP, current US$) of Kazakhstan in 2013?
Your response must be concise. 1.49e+1. What is the difference between the Payments (BoP, current US$) of Argentina in 2011 and the Payments (BoP, current US$) of Lebanon in 2013?
Give a very brief answer. 7.02e+1. What is the difference between the Payments (BoP, current US$) of Argentina in 2011 and the Payments (BoP, current US$) of Uruguay in 2013?
Make the answer very short. 8.75e+1. What is the difference between the Payments (BoP, current US$) of Kazakhstan in 2011 and the Payments (BoP, current US$) of Lebanon in 2013?
Your answer should be compact. 4.71e+1. What is the difference between the Payments (BoP, current US$) in Kazakhstan in 2011 and the Payments (BoP, current US$) in Uruguay in 2013?
Offer a very short reply. 6.43e+1. What is the difference between the Payments (BoP, current US$) in Lebanon in 2011 and the Payments (BoP, current US$) in Uruguay in 2013?
Your answer should be very brief. 1.71e+1. What is the difference between the Payments (BoP, current US$) of Argentina in 2012 and the Payments (BoP, current US$) of Kazakhstan in 2013?
Offer a terse response. 8.76e+09. What is the difference between the Payments (BoP, current US$) of Argentina in 2012 and the Payments (BoP, current US$) of Lebanon in 2013?
Make the answer very short. 6.40e+1. What is the difference between the Payments (BoP, current US$) of Argentina in 2012 and the Payments (BoP, current US$) of Uruguay in 2013?
Your response must be concise. 8.13e+1. What is the difference between the Payments (BoP, current US$) of Kazakhstan in 2012 and the Payments (BoP, current US$) of Lebanon in 2013?
Give a very brief answer. 5.75e+1. What is the difference between the Payments (BoP, current US$) of Kazakhstan in 2012 and the Payments (BoP, current US$) of Uruguay in 2013?
Provide a short and direct response. 7.48e+1. What is the difference between the Payments (BoP, current US$) in Lebanon in 2012 and the Payments (BoP, current US$) in Uruguay in 2013?
Provide a short and direct response. 1.67e+1. What is the average Payments (BoP, current US$) of Argentina per year?
Your answer should be very brief. 8.52e+1. What is the average Payments (BoP, current US$) in Kazakhstan per year?
Your answer should be very brief. 7.40e+1. What is the average Payments (BoP, current US$) in Lebanon per year?
Your answer should be very brief. 3.16e+1. What is the average Payments (BoP, current US$) of Uruguay per year?
Your response must be concise. 1.29e+1. In the year 2007, what is the difference between the Payments (BoP, current US$) in Argentina and Payments (BoP, current US$) in Kazakhstan?
Your response must be concise. 4.04e+09. In the year 2007, what is the difference between the Payments (BoP, current US$) in Argentina and Payments (BoP, current US$) in Lebanon?
Make the answer very short. 4.20e+1. In the year 2007, what is the difference between the Payments (BoP, current US$) of Argentina and Payments (BoP, current US$) of Uruguay?
Ensure brevity in your answer.  5.76e+1. In the year 2007, what is the difference between the Payments (BoP, current US$) of Kazakhstan and Payments (BoP, current US$) of Lebanon?
Give a very brief answer. 3.79e+1. In the year 2007, what is the difference between the Payments (BoP, current US$) in Kazakhstan and Payments (BoP, current US$) in Uruguay?
Keep it short and to the point. 5.36e+1. In the year 2007, what is the difference between the Payments (BoP, current US$) of Lebanon and Payments (BoP, current US$) of Uruguay?
Your response must be concise. 1.56e+1. In the year 2008, what is the difference between the Payments (BoP, current US$) in Argentina and Payments (BoP, current US$) in Kazakhstan?
Your answer should be compact. 8.34e+09. In the year 2008, what is the difference between the Payments (BoP, current US$) of Argentina and Payments (BoP, current US$) of Lebanon?
Offer a terse response. 4.97e+1. In the year 2008, what is the difference between the Payments (BoP, current US$) of Argentina and Payments (BoP, current US$) of Uruguay?
Give a very brief answer. 6.90e+1. In the year 2008, what is the difference between the Payments (BoP, current US$) in Kazakhstan and Payments (BoP, current US$) in Lebanon?
Keep it short and to the point. 4.14e+1. In the year 2008, what is the difference between the Payments (BoP, current US$) of Kazakhstan and Payments (BoP, current US$) of Uruguay?
Provide a succinct answer. 6.07e+1. In the year 2008, what is the difference between the Payments (BoP, current US$) of Lebanon and Payments (BoP, current US$) of Uruguay?
Offer a terse response. 1.93e+1. In the year 2009, what is the difference between the Payments (BoP, current US$) of Argentina and Payments (BoP, current US$) of Kazakhstan?
Make the answer very short. 7.11e+09. In the year 2009, what is the difference between the Payments (BoP, current US$) of Argentina and Payments (BoP, current US$) of Lebanon?
Your response must be concise. 3.00e+1. In the year 2009, what is the difference between the Payments (BoP, current US$) in Argentina and Payments (BoP, current US$) in Uruguay?
Provide a succinct answer. 5.19e+1. In the year 2009, what is the difference between the Payments (BoP, current US$) in Kazakhstan and Payments (BoP, current US$) in Lebanon?
Provide a succinct answer. 2.29e+1. In the year 2009, what is the difference between the Payments (BoP, current US$) in Kazakhstan and Payments (BoP, current US$) in Uruguay?
Provide a short and direct response. 4.48e+1. In the year 2009, what is the difference between the Payments (BoP, current US$) of Lebanon and Payments (BoP, current US$) of Uruguay?
Your response must be concise. 2.19e+1. In the year 2010, what is the difference between the Payments (BoP, current US$) of Argentina and Payments (BoP, current US$) of Kazakhstan?
Provide a short and direct response. 1.63e+1. In the year 2010, what is the difference between the Payments (BoP, current US$) of Argentina and Payments (BoP, current US$) of Lebanon?
Ensure brevity in your answer.  5.04e+1. In the year 2010, what is the difference between the Payments (BoP, current US$) in Argentina and Payments (BoP, current US$) in Uruguay?
Provide a short and direct response. 7.06e+1. In the year 2010, what is the difference between the Payments (BoP, current US$) in Kazakhstan and Payments (BoP, current US$) in Lebanon?
Keep it short and to the point. 3.42e+1. In the year 2010, what is the difference between the Payments (BoP, current US$) of Kazakhstan and Payments (BoP, current US$) of Uruguay?
Offer a terse response. 5.43e+1. In the year 2010, what is the difference between the Payments (BoP, current US$) of Lebanon and Payments (BoP, current US$) of Uruguay?
Make the answer very short. 2.01e+1. In the year 2011, what is the difference between the Payments (BoP, current US$) in Argentina and Payments (BoP, current US$) in Kazakhstan?
Offer a very short reply. 2.31e+1. In the year 2011, what is the difference between the Payments (BoP, current US$) of Argentina and Payments (BoP, current US$) of Lebanon?
Make the answer very short. 7.04e+1. In the year 2011, what is the difference between the Payments (BoP, current US$) of Argentina and Payments (BoP, current US$) of Uruguay?
Keep it short and to the point. 8.95e+1. In the year 2011, what is the difference between the Payments (BoP, current US$) of Kazakhstan and Payments (BoP, current US$) of Lebanon?
Provide a short and direct response. 4.72e+1. In the year 2011, what is the difference between the Payments (BoP, current US$) in Kazakhstan and Payments (BoP, current US$) in Uruguay?
Make the answer very short. 6.64e+1. In the year 2011, what is the difference between the Payments (BoP, current US$) in Lebanon and Payments (BoP, current US$) in Uruguay?
Keep it short and to the point. 1.92e+1. In the year 2012, what is the difference between the Payments (BoP, current US$) in Argentina and Payments (BoP, current US$) in Kazakhstan?
Offer a terse response. 6.53e+09. In the year 2012, what is the difference between the Payments (BoP, current US$) of Argentina and Payments (BoP, current US$) of Lebanon?
Ensure brevity in your answer.  6.46e+1. In the year 2012, what is the difference between the Payments (BoP, current US$) in Argentina and Payments (BoP, current US$) in Uruguay?
Your response must be concise. 8.17e+1. In the year 2012, what is the difference between the Payments (BoP, current US$) of Kazakhstan and Payments (BoP, current US$) of Lebanon?
Ensure brevity in your answer.  5.81e+1. In the year 2012, what is the difference between the Payments (BoP, current US$) in Kazakhstan and Payments (BoP, current US$) in Uruguay?
Keep it short and to the point. 7.52e+1. In the year 2012, what is the difference between the Payments (BoP, current US$) of Lebanon and Payments (BoP, current US$) of Uruguay?
Give a very brief answer. 1.71e+1. In the year 2013, what is the difference between the Payments (BoP, current US$) of Argentina and Payments (BoP, current US$) of Kazakhstan?
Give a very brief answer. 1.32e+1. In the year 2013, what is the difference between the Payments (BoP, current US$) of Argentina and Payments (BoP, current US$) of Lebanon?
Provide a short and direct response. 6.85e+1. In the year 2013, what is the difference between the Payments (BoP, current US$) of Argentina and Payments (BoP, current US$) of Uruguay?
Your answer should be compact. 8.58e+1. In the year 2013, what is the difference between the Payments (BoP, current US$) in Kazakhstan and Payments (BoP, current US$) in Lebanon?
Your response must be concise. 5.53e+1. In the year 2013, what is the difference between the Payments (BoP, current US$) in Kazakhstan and Payments (BoP, current US$) in Uruguay?
Your response must be concise. 7.26e+1. In the year 2013, what is the difference between the Payments (BoP, current US$) in Lebanon and Payments (BoP, current US$) in Uruguay?
Offer a very short reply. 1.73e+1. What is the ratio of the Payments (BoP, current US$) of Argentina in 2007 to that in 2008?
Ensure brevity in your answer.  0.81. What is the ratio of the Payments (BoP, current US$) in Kazakhstan in 2007 to that in 2008?
Your response must be concise. 0.85. What is the ratio of the Payments (BoP, current US$) of Lebanon in 2007 to that in 2008?
Provide a short and direct response. 0.76. What is the ratio of the Payments (BoP, current US$) in Uruguay in 2007 to that in 2008?
Provide a succinct answer. 0.68. What is the ratio of the Payments (BoP, current US$) of Argentina in 2007 to that in 2009?
Offer a terse response. 1.07. What is the ratio of the Payments (BoP, current US$) of Kazakhstan in 2007 to that in 2009?
Keep it short and to the point. 1.13. What is the ratio of the Payments (BoP, current US$) in Lebanon in 2007 to that in 2009?
Your answer should be very brief. 0.75. What is the ratio of the Payments (BoP, current US$) of Uruguay in 2007 to that in 2009?
Your answer should be very brief. 0.84. What is the ratio of the Payments (BoP, current US$) of Argentina in 2007 to that in 2010?
Your answer should be compact. 0.8. What is the ratio of the Payments (BoP, current US$) in Kazakhstan in 2007 to that in 2010?
Ensure brevity in your answer.  0.93. What is the ratio of the Payments (BoP, current US$) of Lebanon in 2007 to that in 2010?
Offer a terse response. 0.74. What is the ratio of the Payments (BoP, current US$) of Uruguay in 2007 to that in 2010?
Offer a terse response. 0.68. What is the ratio of the Payments (BoP, current US$) of Argentina in 2007 to that in 2011?
Give a very brief answer. 0.63. What is the ratio of the Payments (BoP, current US$) of Kazakhstan in 2007 to that in 2011?
Offer a terse response. 0.76. What is the ratio of the Payments (BoP, current US$) in Lebanon in 2007 to that in 2011?
Ensure brevity in your answer.  0.7. What is the ratio of the Payments (BoP, current US$) in Uruguay in 2007 to that in 2011?
Provide a succinct answer. 0.55. What is the ratio of the Payments (BoP, current US$) of Argentina in 2007 to that in 2012?
Keep it short and to the point. 0.67. What is the ratio of the Payments (BoP, current US$) in Kazakhstan in 2007 to that in 2012?
Offer a terse response. 0.67. What is the ratio of the Payments (BoP, current US$) in Lebanon in 2007 to that in 2012?
Offer a terse response. 0.71. What is the ratio of the Payments (BoP, current US$) in Uruguay in 2007 to that in 2012?
Keep it short and to the point. 0.49. What is the ratio of the Payments (BoP, current US$) of Argentina in 2007 to that in 2013?
Offer a terse response. 0.64. What is the ratio of the Payments (BoP, current US$) of Kazakhstan in 2007 to that in 2013?
Make the answer very short. 0.69. What is the ratio of the Payments (BoP, current US$) of Lebanon in 2007 to that in 2013?
Make the answer very short. 0.7. What is the ratio of the Payments (BoP, current US$) of Uruguay in 2007 to that in 2013?
Give a very brief answer. 0.48. What is the ratio of the Payments (BoP, current US$) of Argentina in 2008 to that in 2009?
Your response must be concise. 1.31. What is the ratio of the Payments (BoP, current US$) of Kazakhstan in 2008 to that in 2009?
Provide a short and direct response. 1.33. What is the ratio of the Payments (BoP, current US$) of Lebanon in 2008 to that in 2009?
Your answer should be compact. 0.99. What is the ratio of the Payments (BoP, current US$) of Uruguay in 2008 to that in 2009?
Offer a terse response. 1.23. What is the ratio of the Payments (BoP, current US$) of Argentina in 2008 to that in 2010?
Offer a very short reply. 0.98. What is the ratio of the Payments (BoP, current US$) of Kazakhstan in 2008 to that in 2010?
Offer a terse response. 1.1. What is the ratio of the Payments (BoP, current US$) of Lebanon in 2008 to that in 2010?
Keep it short and to the point. 0.97. What is the ratio of the Payments (BoP, current US$) in Uruguay in 2008 to that in 2010?
Offer a terse response. 1. What is the ratio of the Payments (BoP, current US$) of Argentina in 2008 to that in 2011?
Make the answer very short. 0.78. What is the ratio of the Payments (BoP, current US$) in Kazakhstan in 2008 to that in 2011?
Your answer should be very brief. 0.89. What is the ratio of the Payments (BoP, current US$) of Lebanon in 2008 to that in 2011?
Offer a terse response. 0.92. What is the ratio of the Payments (BoP, current US$) in Uruguay in 2008 to that in 2011?
Provide a succinct answer. 0.81. What is the ratio of the Payments (BoP, current US$) of Argentina in 2008 to that in 2012?
Provide a succinct answer. 0.82. What is the ratio of the Payments (BoP, current US$) of Kazakhstan in 2008 to that in 2012?
Offer a very short reply. 0.79. What is the ratio of the Payments (BoP, current US$) of Uruguay in 2008 to that in 2012?
Give a very brief answer. 0.72. What is the ratio of the Payments (BoP, current US$) of Argentina in 2008 to that in 2013?
Your answer should be very brief. 0.79. What is the ratio of the Payments (BoP, current US$) of Kazakhstan in 2008 to that in 2013?
Your answer should be compact. 0.81. What is the ratio of the Payments (BoP, current US$) of Lebanon in 2008 to that in 2013?
Give a very brief answer. 0.91. What is the ratio of the Payments (BoP, current US$) of Uruguay in 2008 to that in 2013?
Your response must be concise. 0.71. What is the ratio of the Payments (BoP, current US$) in Argentina in 2009 to that in 2010?
Your answer should be compact. 0.75. What is the ratio of the Payments (BoP, current US$) of Kazakhstan in 2009 to that in 2010?
Your response must be concise. 0.82. What is the ratio of the Payments (BoP, current US$) of Lebanon in 2009 to that in 2010?
Offer a very short reply. 0.99. What is the ratio of the Payments (BoP, current US$) in Uruguay in 2009 to that in 2010?
Provide a succinct answer. 0.81. What is the ratio of the Payments (BoP, current US$) of Argentina in 2009 to that in 2011?
Give a very brief answer. 0.59. What is the ratio of the Payments (BoP, current US$) in Kazakhstan in 2009 to that in 2011?
Ensure brevity in your answer.  0.67. What is the ratio of the Payments (BoP, current US$) in Lebanon in 2009 to that in 2011?
Give a very brief answer. 0.93. What is the ratio of the Payments (BoP, current US$) in Uruguay in 2009 to that in 2011?
Ensure brevity in your answer.  0.66. What is the ratio of the Payments (BoP, current US$) in Argentina in 2009 to that in 2012?
Give a very brief answer. 0.63. What is the ratio of the Payments (BoP, current US$) of Kazakhstan in 2009 to that in 2012?
Keep it short and to the point. 0.59. What is the ratio of the Payments (BoP, current US$) in Lebanon in 2009 to that in 2012?
Offer a very short reply. 0.94. What is the ratio of the Payments (BoP, current US$) of Uruguay in 2009 to that in 2012?
Your response must be concise. 0.59. What is the ratio of the Payments (BoP, current US$) in Argentina in 2009 to that in 2013?
Offer a terse response. 0.6. What is the ratio of the Payments (BoP, current US$) in Kazakhstan in 2009 to that in 2013?
Offer a terse response. 0.61. What is the ratio of the Payments (BoP, current US$) of Lebanon in 2009 to that in 2013?
Offer a terse response. 0.93. What is the ratio of the Payments (BoP, current US$) in Uruguay in 2009 to that in 2013?
Your answer should be very brief. 0.58. What is the ratio of the Payments (BoP, current US$) in Argentina in 2010 to that in 2011?
Offer a very short reply. 0.79. What is the ratio of the Payments (BoP, current US$) of Kazakhstan in 2010 to that in 2011?
Make the answer very short. 0.82. What is the ratio of the Payments (BoP, current US$) in Lebanon in 2010 to that in 2011?
Your response must be concise. 0.94. What is the ratio of the Payments (BoP, current US$) of Uruguay in 2010 to that in 2011?
Give a very brief answer. 0.81. What is the ratio of the Payments (BoP, current US$) in Argentina in 2010 to that in 2012?
Ensure brevity in your answer.  0.84. What is the ratio of the Payments (BoP, current US$) in Kazakhstan in 2010 to that in 2012?
Offer a very short reply. 0.72. What is the ratio of the Payments (BoP, current US$) in Lebanon in 2010 to that in 2012?
Make the answer very short. 0.96. What is the ratio of the Payments (BoP, current US$) of Uruguay in 2010 to that in 2012?
Your answer should be compact. 0.73. What is the ratio of the Payments (BoP, current US$) in Argentina in 2010 to that in 2013?
Ensure brevity in your answer.  0.8. What is the ratio of the Payments (BoP, current US$) in Kazakhstan in 2010 to that in 2013?
Provide a succinct answer. 0.74. What is the ratio of the Payments (BoP, current US$) in Lebanon in 2010 to that in 2013?
Offer a very short reply. 0.94. What is the ratio of the Payments (BoP, current US$) in Uruguay in 2010 to that in 2013?
Ensure brevity in your answer.  0.71. What is the ratio of the Payments (BoP, current US$) in Kazakhstan in 2011 to that in 2012?
Keep it short and to the point. 0.89. What is the ratio of the Payments (BoP, current US$) of Lebanon in 2011 to that in 2012?
Give a very brief answer. 1.01. What is the ratio of the Payments (BoP, current US$) of Uruguay in 2011 to that in 2012?
Your answer should be very brief. 0.9. What is the ratio of the Payments (BoP, current US$) in Argentina in 2011 to that in 2013?
Make the answer very short. 1.02. What is the ratio of the Payments (BoP, current US$) of Kazakhstan in 2011 to that in 2013?
Your response must be concise. 0.91. What is the ratio of the Payments (BoP, current US$) in Lebanon in 2011 to that in 2013?
Provide a short and direct response. 0.99. What is the ratio of the Payments (BoP, current US$) in Uruguay in 2011 to that in 2013?
Ensure brevity in your answer.  0.88. What is the ratio of the Payments (BoP, current US$) of Argentina in 2012 to that in 2013?
Keep it short and to the point. 0.96. What is the ratio of the Payments (BoP, current US$) in Kazakhstan in 2012 to that in 2013?
Offer a terse response. 1.02. What is the ratio of the Payments (BoP, current US$) of Lebanon in 2012 to that in 2013?
Make the answer very short. 0.98. What is the ratio of the Payments (BoP, current US$) of Uruguay in 2012 to that in 2013?
Provide a succinct answer. 0.98. What is the difference between the highest and the second highest Payments (BoP, current US$) in Argentina?
Your answer should be compact. 1.70e+09. What is the difference between the highest and the second highest Payments (BoP, current US$) of Kazakhstan?
Your response must be concise. 2.23e+09. What is the difference between the highest and the second highest Payments (BoP, current US$) in Lebanon?
Give a very brief answer. 1.74e+08. What is the difference between the highest and the second highest Payments (BoP, current US$) in Uruguay?
Offer a very short reply. 3.80e+08. What is the difference between the highest and the lowest Payments (BoP, current US$) of Argentina?
Make the answer very short. 4.27e+1. What is the difference between the highest and the lowest Payments (BoP, current US$) in Kazakhstan?
Provide a short and direct response. 3.72e+1. What is the difference between the highest and the lowest Payments (BoP, current US$) in Lebanon?
Your answer should be very brief. 1.04e+1. What is the difference between the highest and the lowest Payments (BoP, current US$) in Uruguay?
Give a very brief answer. 8.79e+09. 